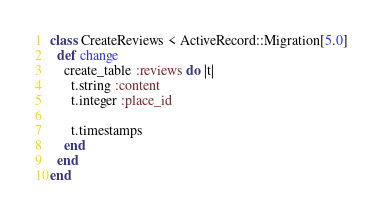Convert code to text. <code><loc_0><loc_0><loc_500><loc_500><_Ruby_>class CreateReviews < ActiveRecord::Migration[5.0]
  def change
    create_table :reviews do |t|
      t.string :content
      t.integer :place_id
      
      t.timestamps
    end
  end
end
</code> 